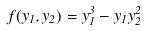Convert formula to latex. <formula><loc_0><loc_0><loc_500><loc_500>f ( y _ { 1 } , y _ { 2 } ) = y _ { 1 } ^ { 3 } - y _ { 1 } y _ { 2 } ^ { 2 }</formula> 